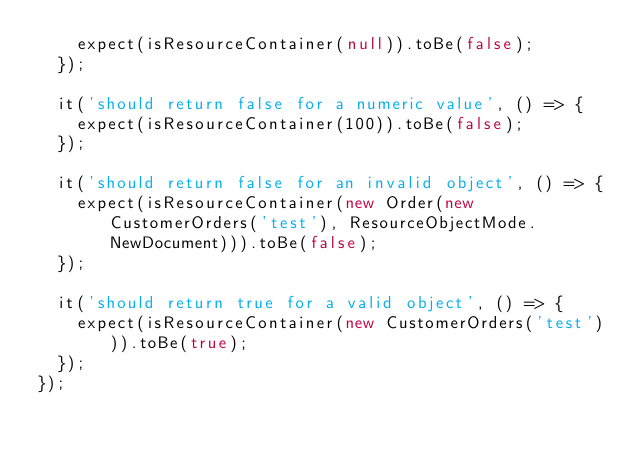<code> <loc_0><loc_0><loc_500><loc_500><_TypeScript_>    expect(isResourceContainer(null)).toBe(false);
  });

  it('should return false for a numeric value', () => {
    expect(isResourceContainer(100)).toBe(false);
  });

  it('should return false for an invalid object', () => {
    expect(isResourceContainer(new Order(new CustomerOrders('test'), ResourceObjectMode.NewDocument))).toBe(false);
  });

  it('should return true for a valid object', () => {
    expect(isResourceContainer(new CustomerOrders('test'))).toBe(true);
  });
});
</code> 